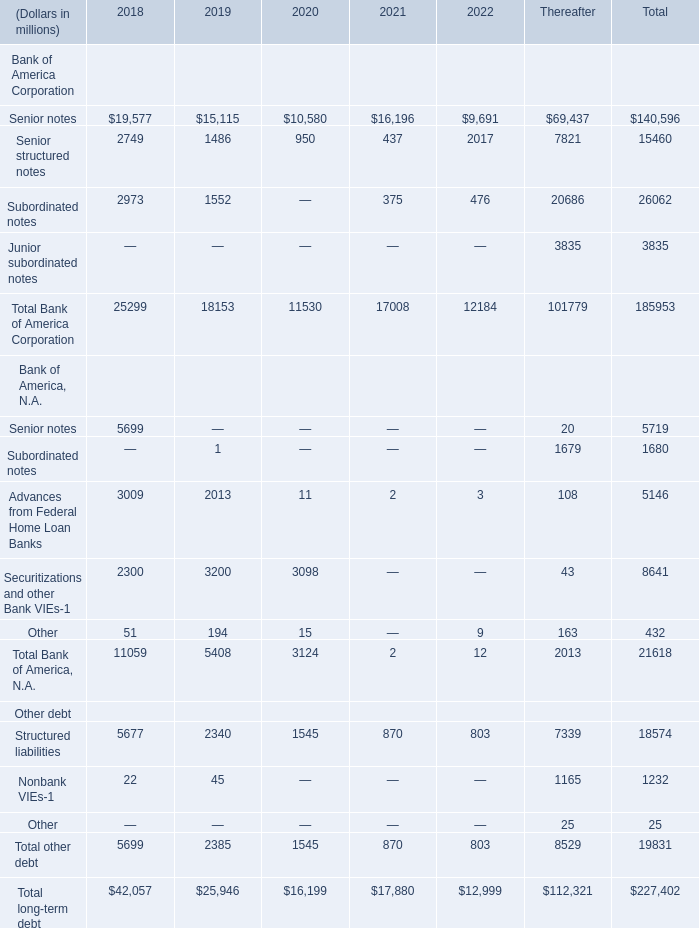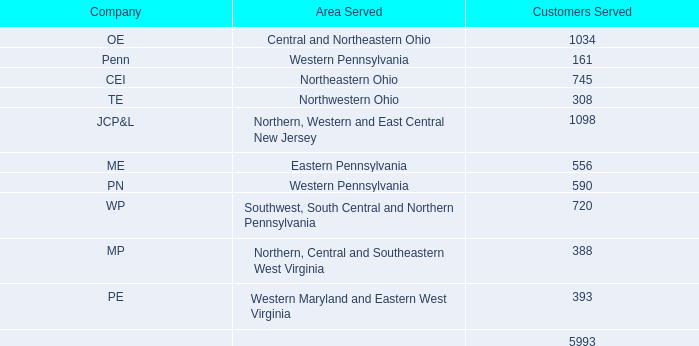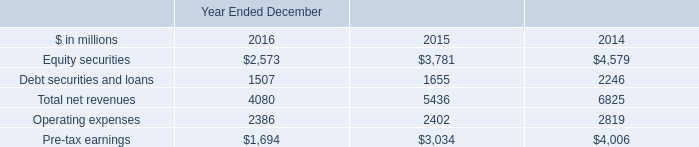operating expenses were what multiple of pre-tax earnings in 2015? 
Computations: (13.94 / 1.21)
Answer: 11.52066. 